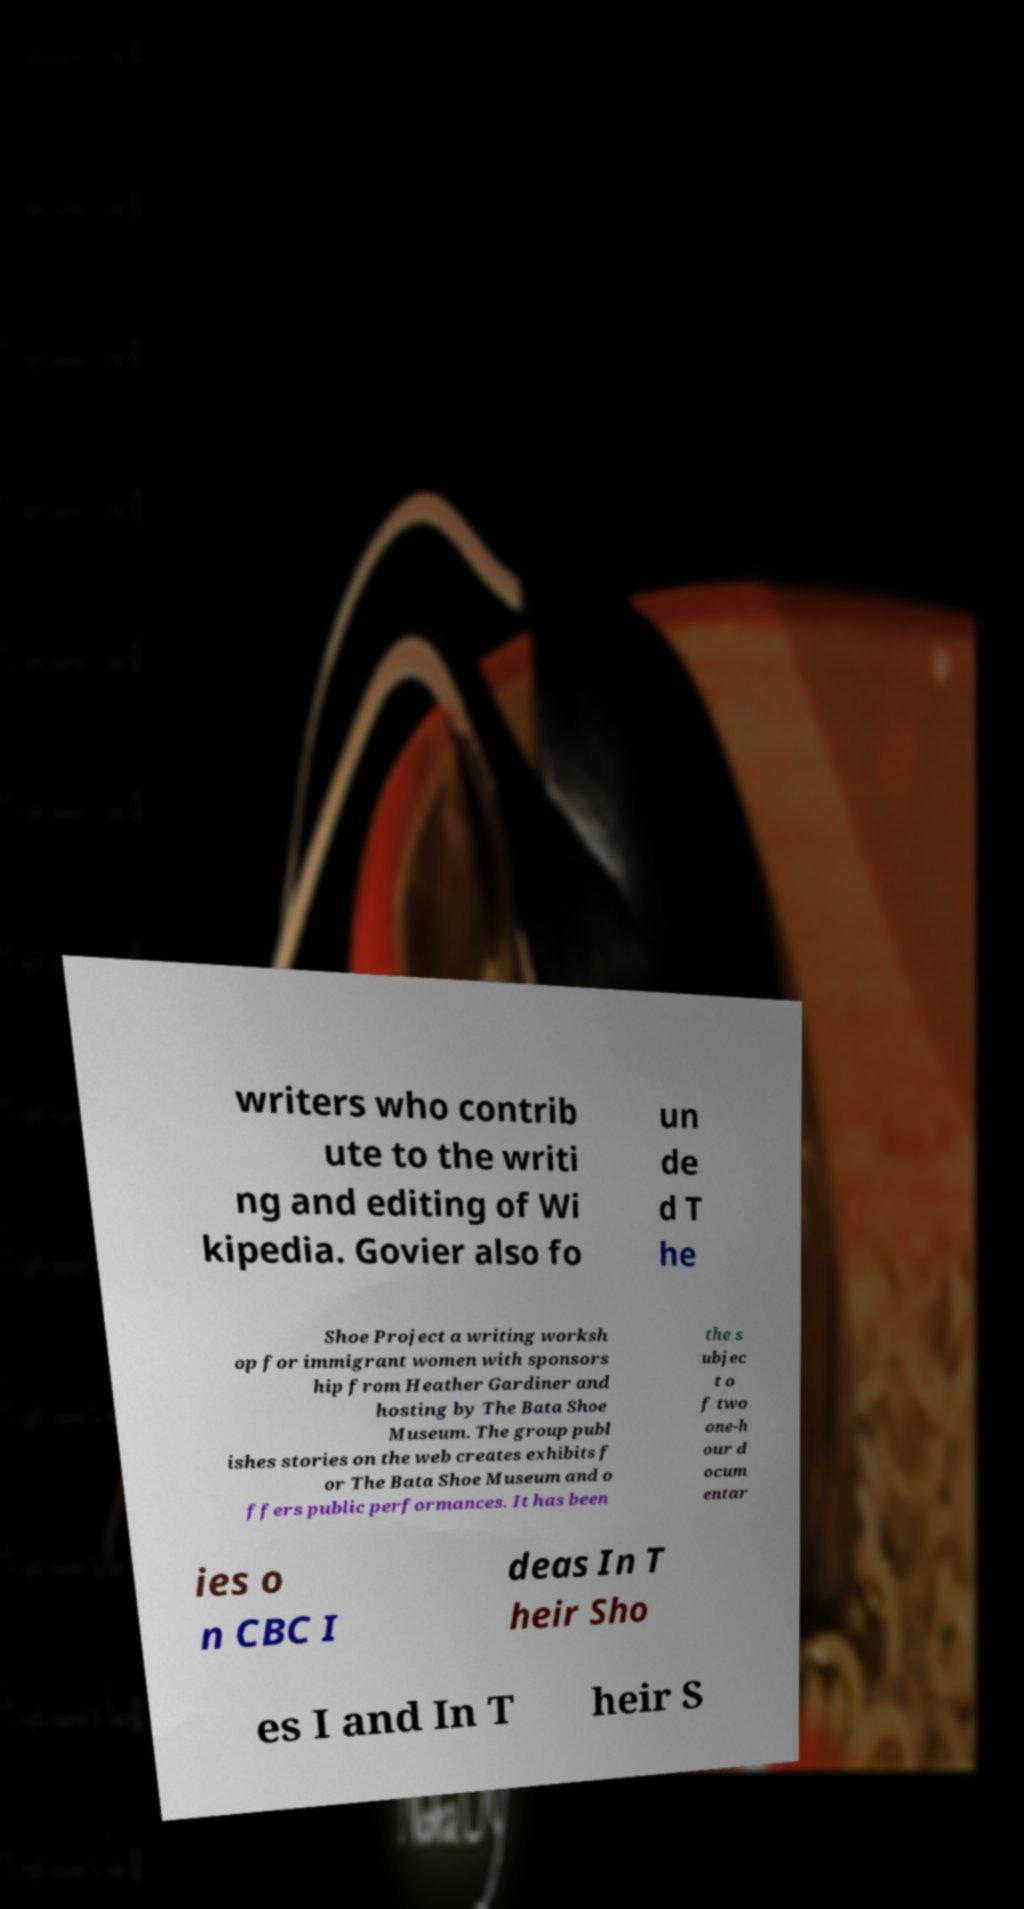Can you accurately transcribe the text from the provided image for me? writers who contrib ute to the writi ng and editing of Wi kipedia. Govier also fo un de d T he Shoe Project a writing worksh op for immigrant women with sponsors hip from Heather Gardiner and hosting by The Bata Shoe Museum. The group publ ishes stories on the web creates exhibits f or The Bata Shoe Museum and o ffers public performances. It has been the s ubjec t o f two one-h our d ocum entar ies o n CBC I deas In T heir Sho es I and In T heir S 